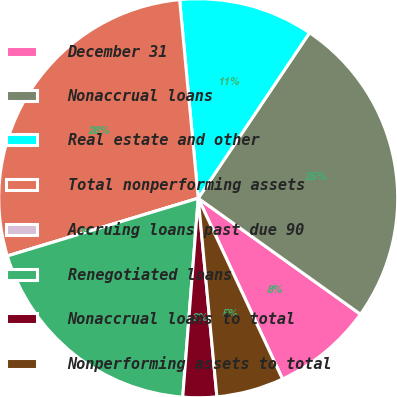<chart> <loc_0><loc_0><loc_500><loc_500><pie_chart><fcel>December 31<fcel>Nonaccrual loans<fcel>Real estate and other<fcel>Total nonperforming assets<fcel>Accruing loans past due 90<fcel>Renegotiated loans<fcel>Nonaccrual loans to total<fcel>Nonperforming assets to total<nl><fcel>8.18%<fcel>25.46%<fcel>10.91%<fcel>28.19%<fcel>0.0%<fcel>19.09%<fcel>2.73%<fcel>5.45%<nl></chart> 